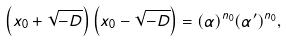Convert formula to latex. <formula><loc_0><loc_0><loc_500><loc_500>\left ( x _ { 0 } + \sqrt { - D } \right ) \left ( x _ { 0 } - \sqrt { - D } \right ) = ( \alpha ) ^ { n _ { 0 } } ( \alpha ^ { \prime } ) ^ { n _ { 0 } } ,</formula> 